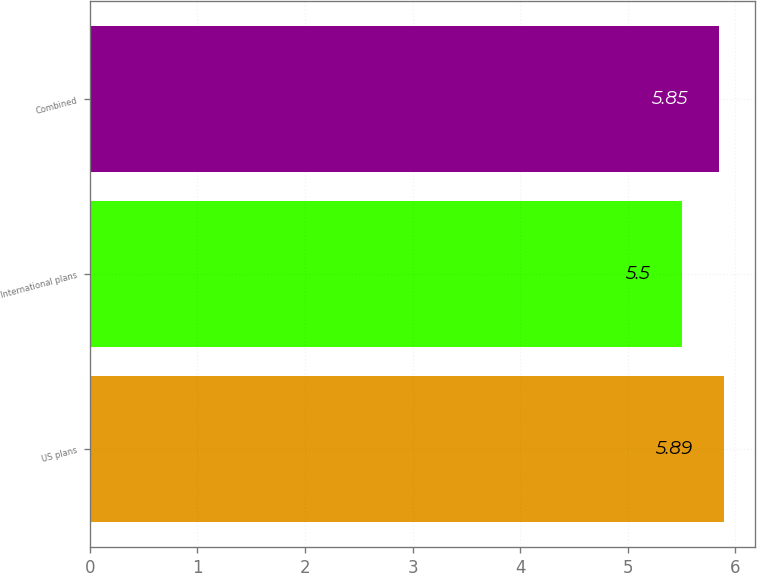Convert chart. <chart><loc_0><loc_0><loc_500><loc_500><bar_chart><fcel>US plans<fcel>International plans<fcel>Combined<nl><fcel>5.89<fcel>5.5<fcel>5.85<nl></chart> 